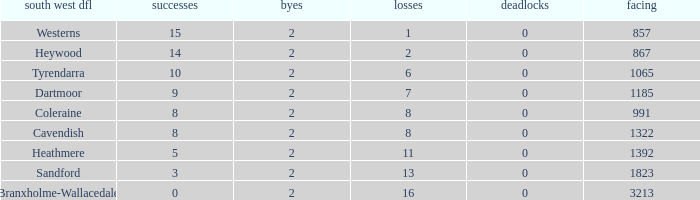Which draws have an average of 14 wins? 0.0. 